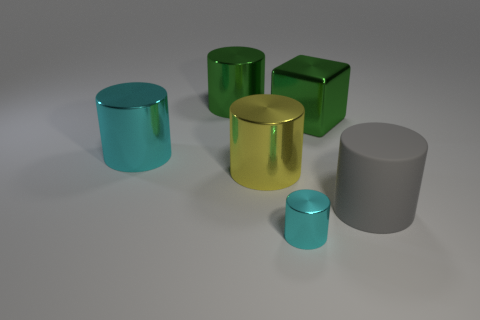Subtract all yellow cylinders. How many cylinders are left? 4 Add 3 large blocks. How many objects exist? 9 Subtract all cubes. How many objects are left? 5 Add 5 cubes. How many cubes exist? 6 Subtract 0 gray cubes. How many objects are left? 6 Subtract all small gray matte things. Subtract all big yellow metallic cylinders. How many objects are left? 5 Add 2 large things. How many large things are left? 7 